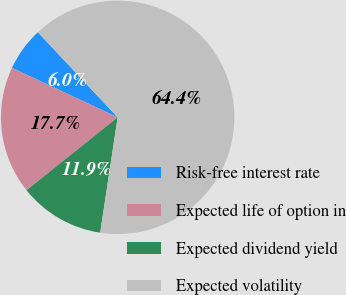<chart> <loc_0><loc_0><loc_500><loc_500><pie_chart><fcel>Risk-free interest rate<fcel>Expected life of option in<fcel>Expected dividend yield<fcel>Expected volatility<nl><fcel>6.04%<fcel>17.71%<fcel>11.87%<fcel>64.39%<nl></chart> 